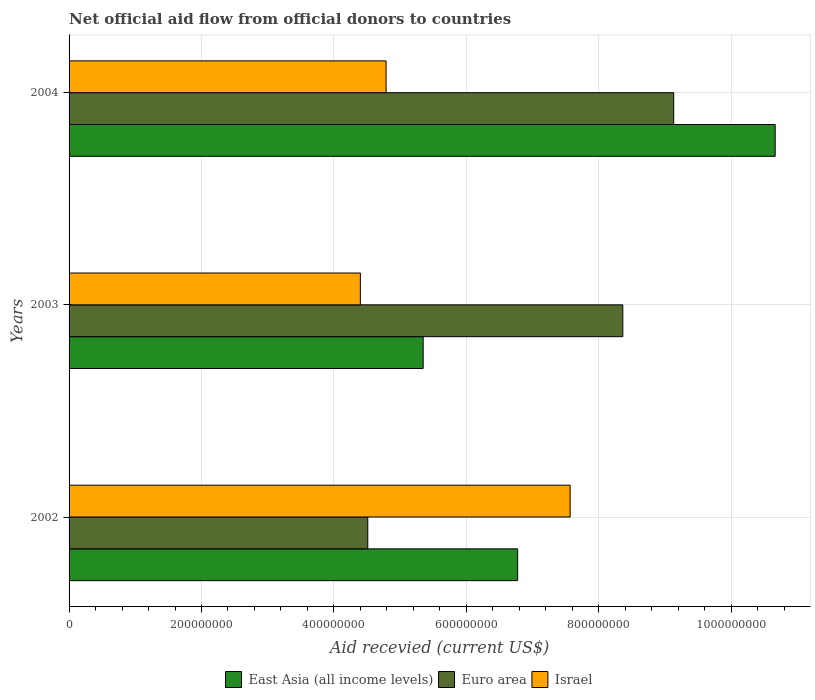Are the number of bars per tick equal to the number of legend labels?
Your response must be concise. Yes. How many bars are there on the 3rd tick from the bottom?
Offer a very short reply. 3. What is the label of the 2nd group of bars from the top?
Ensure brevity in your answer.  2003. What is the total aid received in East Asia (all income levels) in 2002?
Give a very brief answer. 6.78e+08. Across all years, what is the maximum total aid received in Israel?
Give a very brief answer. 7.57e+08. Across all years, what is the minimum total aid received in Euro area?
Your answer should be very brief. 4.51e+08. In which year was the total aid received in Israel minimum?
Your answer should be compact. 2003. What is the total total aid received in Israel in the graph?
Your answer should be very brief. 1.68e+09. What is the difference between the total aid received in Israel in 2002 and that in 2003?
Provide a short and direct response. 3.17e+08. What is the difference between the total aid received in Israel in 2003 and the total aid received in Euro area in 2002?
Ensure brevity in your answer.  -1.12e+07. What is the average total aid received in Israel per year?
Your answer should be very brief. 5.59e+08. In the year 2003, what is the difference between the total aid received in Euro area and total aid received in Israel?
Your answer should be compact. 3.96e+08. What is the ratio of the total aid received in Israel in 2002 to that in 2003?
Keep it short and to the point. 1.72. Is the total aid received in East Asia (all income levels) in 2002 less than that in 2003?
Offer a terse response. No. Is the difference between the total aid received in Euro area in 2003 and 2004 greater than the difference between the total aid received in Israel in 2003 and 2004?
Give a very brief answer. No. What is the difference between the highest and the second highest total aid received in East Asia (all income levels)?
Ensure brevity in your answer.  3.89e+08. What is the difference between the highest and the lowest total aid received in Euro area?
Give a very brief answer. 4.62e+08. In how many years, is the total aid received in Euro area greater than the average total aid received in Euro area taken over all years?
Your answer should be very brief. 2. Is the sum of the total aid received in East Asia (all income levels) in 2002 and 2004 greater than the maximum total aid received in Euro area across all years?
Your answer should be compact. Yes. How many bars are there?
Your answer should be very brief. 9. What is the difference between two consecutive major ticks on the X-axis?
Ensure brevity in your answer.  2.00e+08. Does the graph contain any zero values?
Provide a succinct answer. No. Where does the legend appear in the graph?
Provide a short and direct response. Bottom center. What is the title of the graph?
Keep it short and to the point. Net official aid flow from official donors to countries. What is the label or title of the X-axis?
Provide a succinct answer. Aid recevied (current US$). What is the label or title of the Y-axis?
Your answer should be compact. Years. What is the Aid recevied (current US$) in East Asia (all income levels) in 2002?
Your answer should be compact. 6.78e+08. What is the Aid recevied (current US$) of Euro area in 2002?
Give a very brief answer. 4.51e+08. What is the Aid recevied (current US$) of Israel in 2002?
Give a very brief answer. 7.57e+08. What is the Aid recevied (current US$) of East Asia (all income levels) in 2003?
Give a very brief answer. 5.35e+08. What is the Aid recevied (current US$) of Euro area in 2003?
Provide a short and direct response. 8.36e+08. What is the Aid recevied (current US$) in Israel in 2003?
Provide a short and direct response. 4.40e+08. What is the Aid recevied (current US$) of East Asia (all income levels) in 2004?
Your response must be concise. 1.07e+09. What is the Aid recevied (current US$) in Euro area in 2004?
Keep it short and to the point. 9.13e+08. What is the Aid recevied (current US$) of Israel in 2004?
Offer a very short reply. 4.79e+08. Across all years, what is the maximum Aid recevied (current US$) in East Asia (all income levels)?
Your response must be concise. 1.07e+09. Across all years, what is the maximum Aid recevied (current US$) in Euro area?
Make the answer very short. 9.13e+08. Across all years, what is the maximum Aid recevied (current US$) of Israel?
Keep it short and to the point. 7.57e+08. Across all years, what is the minimum Aid recevied (current US$) in East Asia (all income levels)?
Your answer should be compact. 5.35e+08. Across all years, what is the minimum Aid recevied (current US$) in Euro area?
Keep it short and to the point. 4.51e+08. Across all years, what is the minimum Aid recevied (current US$) in Israel?
Your response must be concise. 4.40e+08. What is the total Aid recevied (current US$) of East Asia (all income levels) in the graph?
Provide a short and direct response. 2.28e+09. What is the total Aid recevied (current US$) of Euro area in the graph?
Your response must be concise. 2.20e+09. What is the total Aid recevied (current US$) of Israel in the graph?
Give a very brief answer. 1.68e+09. What is the difference between the Aid recevied (current US$) in East Asia (all income levels) in 2002 and that in 2003?
Provide a short and direct response. 1.43e+08. What is the difference between the Aid recevied (current US$) of Euro area in 2002 and that in 2003?
Make the answer very short. -3.85e+08. What is the difference between the Aid recevied (current US$) in Israel in 2002 and that in 2003?
Your response must be concise. 3.17e+08. What is the difference between the Aid recevied (current US$) of East Asia (all income levels) in 2002 and that in 2004?
Your response must be concise. -3.89e+08. What is the difference between the Aid recevied (current US$) in Euro area in 2002 and that in 2004?
Ensure brevity in your answer.  -4.62e+08. What is the difference between the Aid recevied (current US$) in Israel in 2002 and that in 2004?
Provide a short and direct response. 2.78e+08. What is the difference between the Aid recevied (current US$) in East Asia (all income levels) in 2003 and that in 2004?
Give a very brief answer. -5.32e+08. What is the difference between the Aid recevied (current US$) of Euro area in 2003 and that in 2004?
Your answer should be very brief. -7.69e+07. What is the difference between the Aid recevied (current US$) of Israel in 2003 and that in 2004?
Your answer should be compact. -3.89e+07. What is the difference between the Aid recevied (current US$) in East Asia (all income levels) in 2002 and the Aid recevied (current US$) in Euro area in 2003?
Ensure brevity in your answer.  -1.59e+08. What is the difference between the Aid recevied (current US$) of East Asia (all income levels) in 2002 and the Aid recevied (current US$) of Israel in 2003?
Provide a short and direct response. 2.38e+08. What is the difference between the Aid recevied (current US$) in Euro area in 2002 and the Aid recevied (current US$) in Israel in 2003?
Your response must be concise. 1.12e+07. What is the difference between the Aid recevied (current US$) of East Asia (all income levels) in 2002 and the Aid recevied (current US$) of Euro area in 2004?
Provide a succinct answer. -2.36e+08. What is the difference between the Aid recevied (current US$) of East Asia (all income levels) in 2002 and the Aid recevied (current US$) of Israel in 2004?
Give a very brief answer. 1.99e+08. What is the difference between the Aid recevied (current US$) of Euro area in 2002 and the Aid recevied (current US$) of Israel in 2004?
Make the answer very short. -2.77e+07. What is the difference between the Aid recevied (current US$) in East Asia (all income levels) in 2003 and the Aid recevied (current US$) in Euro area in 2004?
Give a very brief answer. -3.78e+08. What is the difference between the Aid recevied (current US$) of East Asia (all income levels) in 2003 and the Aid recevied (current US$) of Israel in 2004?
Ensure brevity in your answer.  5.60e+07. What is the difference between the Aid recevied (current US$) in Euro area in 2003 and the Aid recevied (current US$) in Israel in 2004?
Provide a succinct answer. 3.58e+08. What is the average Aid recevied (current US$) in East Asia (all income levels) per year?
Offer a terse response. 7.60e+08. What is the average Aid recevied (current US$) in Euro area per year?
Offer a terse response. 7.34e+08. What is the average Aid recevied (current US$) of Israel per year?
Offer a very short reply. 5.59e+08. In the year 2002, what is the difference between the Aid recevied (current US$) of East Asia (all income levels) and Aid recevied (current US$) of Euro area?
Keep it short and to the point. 2.26e+08. In the year 2002, what is the difference between the Aid recevied (current US$) in East Asia (all income levels) and Aid recevied (current US$) in Israel?
Keep it short and to the point. -7.93e+07. In the year 2002, what is the difference between the Aid recevied (current US$) in Euro area and Aid recevied (current US$) in Israel?
Your answer should be compact. -3.06e+08. In the year 2003, what is the difference between the Aid recevied (current US$) in East Asia (all income levels) and Aid recevied (current US$) in Euro area?
Ensure brevity in your answer.  -3.02e+08. In the year 2003, what is the difference between the Aid recevied (current US$) in East Asia (all income levels) and Aid recevied (current US$) in Israel?
Offer a terse response. 9.49e+07. In the year 2003, what is the difference between the Aid recevied (current US$) in Euro area and Aid recevied (current US$) in Israel?
Offer a terse response. 3.96e+08. In the year 2004, what is the difference between the Aid recevied (current US$) in East Asia (all income levels) and Aid recevied (current US$) in Euro area?
Keep it short and to the point. 1.53e+08. In the year 2004, what is the difference between the Aid recevied (current US$) of East Asia (all income levels) and Aid recevied (current US$) of Israel?
Give a very brief answer. 5.88e+08. In the year 2004, what is the difference between the Aid recevied (current US$) of Euro area and Aid recevied (current US$) of Israel?
Make the answer very short. 4.34e+08. What is the ratio of the Aid recevied (current US$) in East Asia (all income levels) in 2002 to that in 2003?
Your answer should be compact. 1.27. What is the ratio of the Aid recevied (current US$) of Euro area in 2002 to that in 2003?
Keep it short and to the point. 0.54. What is the ratio of the Aid recevied (current US$) of Israel in 2002 to that in 2003?
Ensure brevity in your answer.  1.72. What is the ratio of the Aid recevied (current US$) in East Asia (all income levels) in 2002 to that in 2004?
Your answer should be compact. 0.64. What is the ratio of the Aid recevied (current US$) in Euro area in 2002 to that in 2004?
Provide a short and direct response. 0.49. What is the ratio of the Aid recevied (current US$) in Israel in 2002 to that in 2004?
Provide a succinct answer. 1.58. What is the ratio of the Aid recevied (current US$) in East Asia (all income levels) in 2003 to that in 2004?
Provide a succinct answer. 0.5. What is the ratio of the Aid recevied (current US$) in Euro area in 2003 to that in 2004?
Offer a terse response. 0.92. What is the ratio of the Aid recevied (current US$) in Israel in 2003 to that in 2004?
Give a very brief answer. 0.92. What is the difference between the highest and the second highest Aid recevied (current US$) in East Asia (all income levels)?
Ensure brevity in your answer.  3.89e+08. What is the difference between the highest and the second highest Aid recevied (current US$) of Euro area?
Keep it short and to the point. 7.69e+07. What is the difference between the highest and the second highest Aid recevied (current US$) of Israel?
Ensure brevity in your answer.  2.78e+08. What is the difference between the highest and the lowest Aid recevied (current US$) in East Asia (all income levels)?
Offer a terse response. 5.32e+08. What is the difference between the highest and the lowest Aid recevied (current US$) in Euro area?
Provide a short and direct response. 4.62e+08. What is the difference between the highest and the lowest Aid recevied (current US$) in Israel?
Your answer should be very brief. 3.17e+08. 